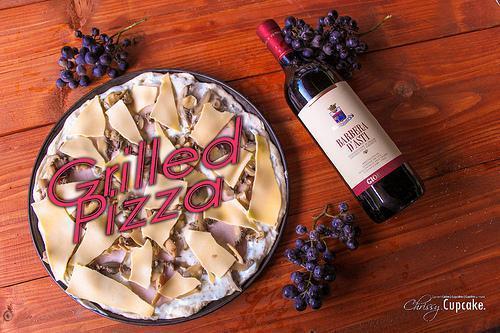How many bunches of grapes are there?
Give a very brief answer. 3. How many bunches of grapes are in the picture?
Give a very brief answer. 3. 